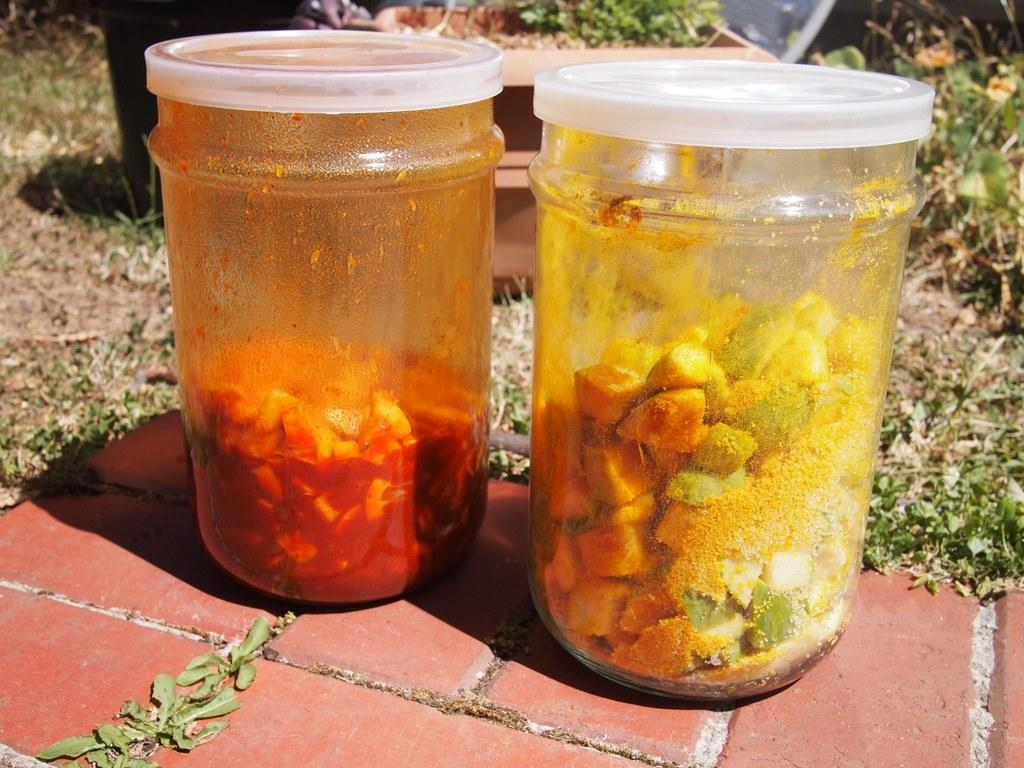What can be seen in the jars in the image? There are two different food items in two different jars in the image. Where are the jars located? The jars are on the floor. What can be seen in the background of the image? There is a potted plant and grass on the land in the background of the image. What type of legal advice is the jar on the left seeking in the image? There is no lawyer or legal advice present in the image; it features two jars with food items on the floor. 